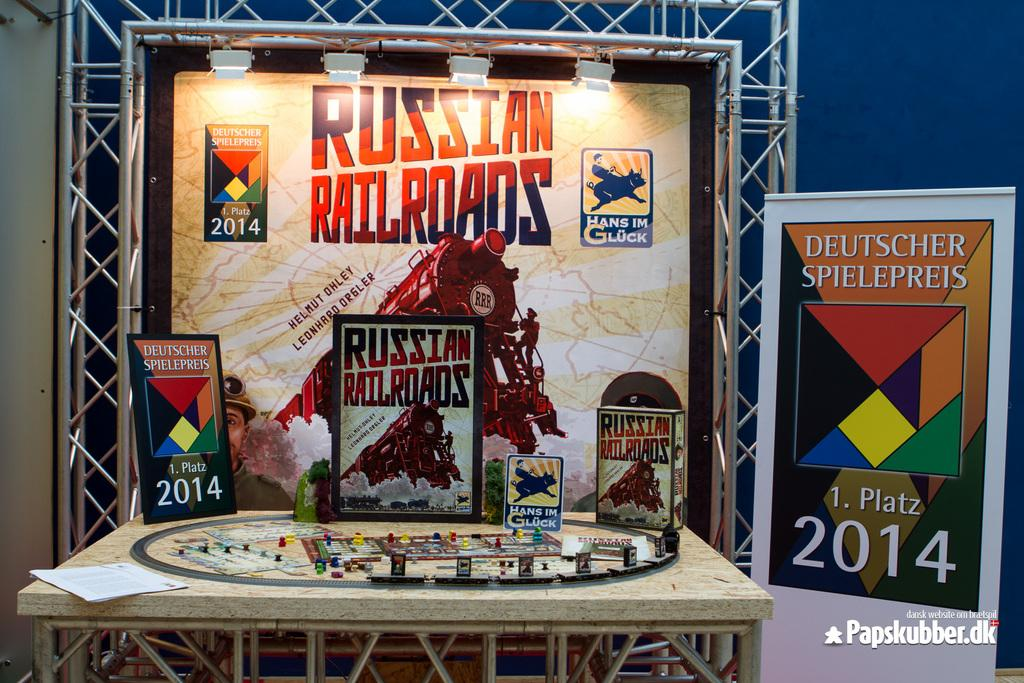<image>
Create a compact narrative representing the image presented. A display of things having to do with the Russian Railroads. 